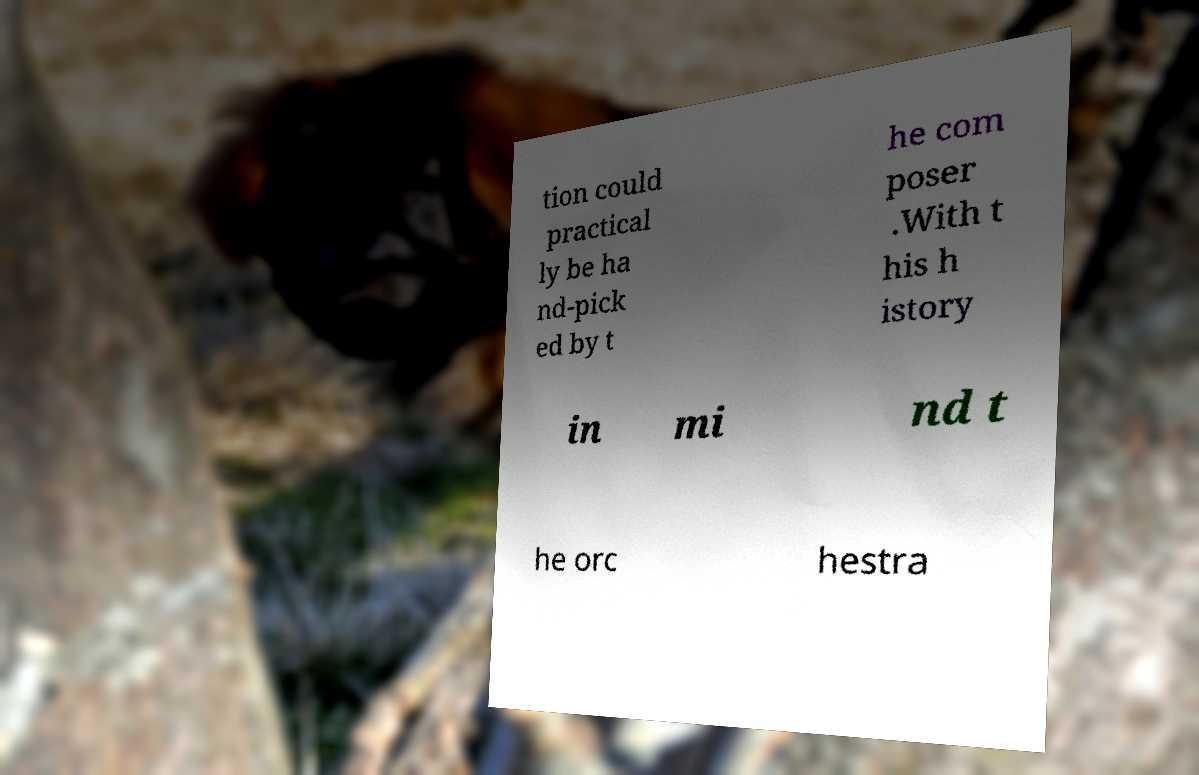I need the written content from this picture converted into text. Can you do that? tion could practical ly be ha nd-pick ed by t he com poser .With t his h istory in mi nd t he orc hestra 